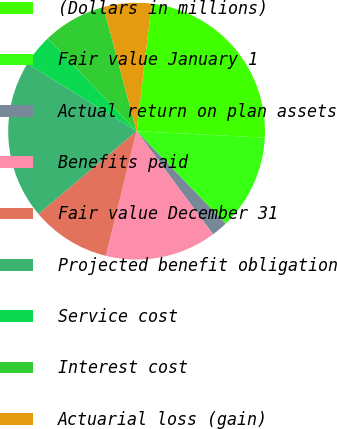Convert chart. <chart><loc_0><loc_0><loc_500><loc_500><pie_chart><fcel>(Dollars in millions)<fcel>Fair value January 1<fcel>Actual return on plan assets<fcel>Benefits paid<fcel>Fair value December 31<fcel>Projected benefit obligation<fcel>Service cost<fcel>Interest cost<fcel>Actuarial loss (gain)<nl><fcel>23.94%<fcel>12.0%<fcel>2.04%<fcel>13.99%<fcel>10.01%<fcel>19.96%<fcel>4.03%<fcel>8.01%<fcel>6.02%<nl></chart> 